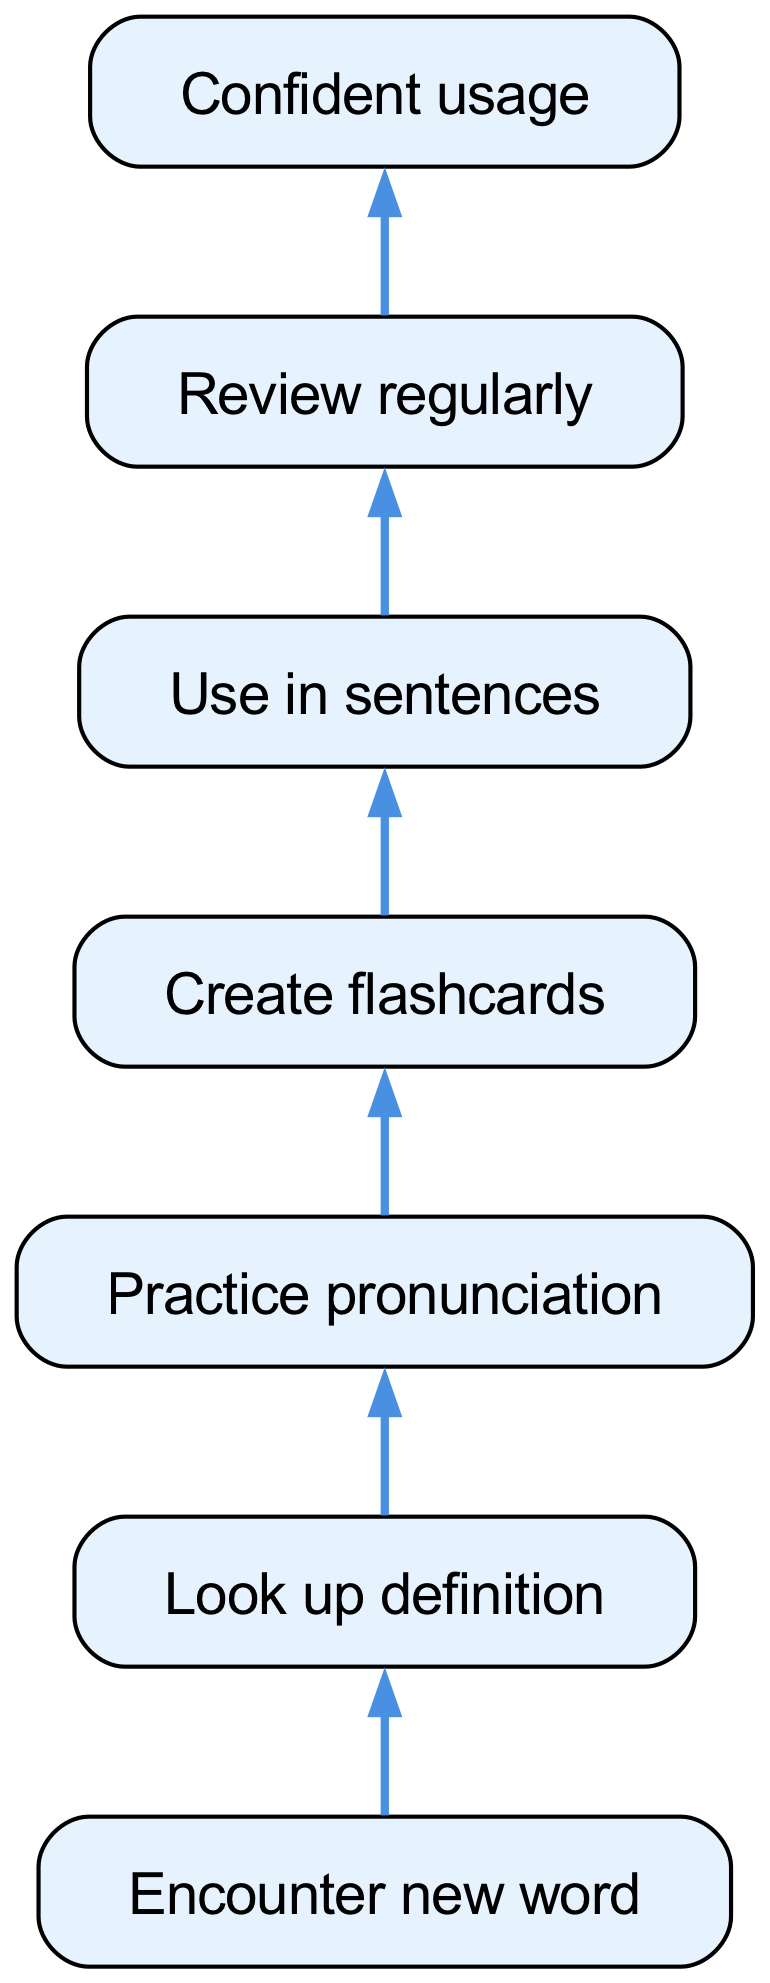What is the first step in the vocabulary learning process? The flow chart begins with the node labeled "Encounter new word," which represents the initial action taken in the vocabulary learning process.
Answer: Encounter new word How many total nodes are in the diagram? By counting each unique node listed, we find there are seven nodes: Encounter new word, Look up definition, Practice pronunciation, Create flashcards, Use in sentences, Review regularly, and Confident usage.
Answer: Seven What action follows "Look up definition"? According to the diagram, the action that follows "Look up definition" is "Practice pronunciation," indicating the next step in the vocabulary learning flow.
Answer: Practice pronunciation What is the last step in the learning process? The final step at the bottom of the chart is "Confident usage," signifying the successful completion of the vocabulary learning journey.
Answer: Confident usage Which two nodes are directly connected to "Practice pronunciation"? From the diagram, "Practice pronunciation" is directly connected to "Look up definition" before it, and "Create flashcards" after it, depicting the sequential steps in learning.
Answer: Look up definition, Create flashcards What is the relationship between "Create flashcards" and "Use in sentences"? The diagram indicates that "Create flashcards" leads directly to "Use in sentences," depicting a clear step in which the vocabulary is practiced contextually.
Answer: Create flashcards leads to Use in sentences How many edges are there in total? The edges connect the nodes, and by counting the connections, we find there are six edges in the diagram, representing the transitions between the steps in the process.
Answer: Six Which node comes before "Review regularly"? In the flow chart, "Use in sentences" is the node that precedes "Review regularly," showing the need to apply sentences before reviewing vocabulary.
Answer: Use in sentences 